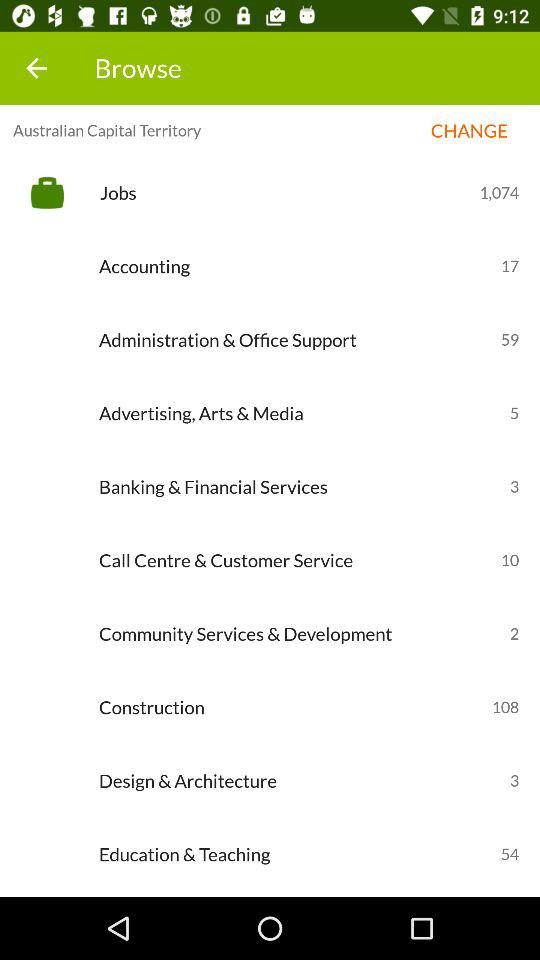What is the current location? The current location is the Australian Capital Territory. 